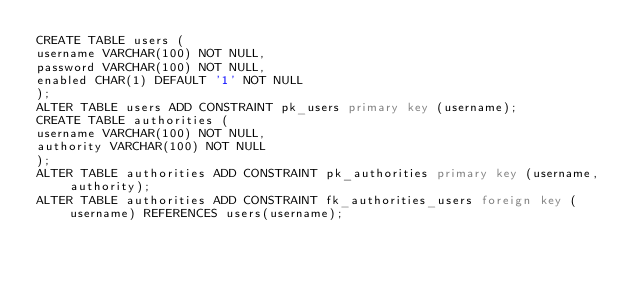<code> <loc_0><loc_0><loc_500><loc_500><_SQL_>CREATE TABLE users (
username VARCHAR(100) NOT NULL,
password VARCHAR(100) NOT NULL,
enabled CHAR(1) DEFAULT '1' NOT NULL
);
ALTER TABLE users ADD CONSTRAINT pk_users primary key (username);
CREATE TABLE authorities (
username VARCHAR(100) NOT NULL,
authority VARCHAR(100) NOT NULL
);
ALTER TABLE authorities ADD CONSTRAINT pk_authorities primary key (username, authority);
ALTER TABLE authorities ADD CONSTRAINT fk_authorities_users foreign key (username) REFERENCES users(username);</code> 